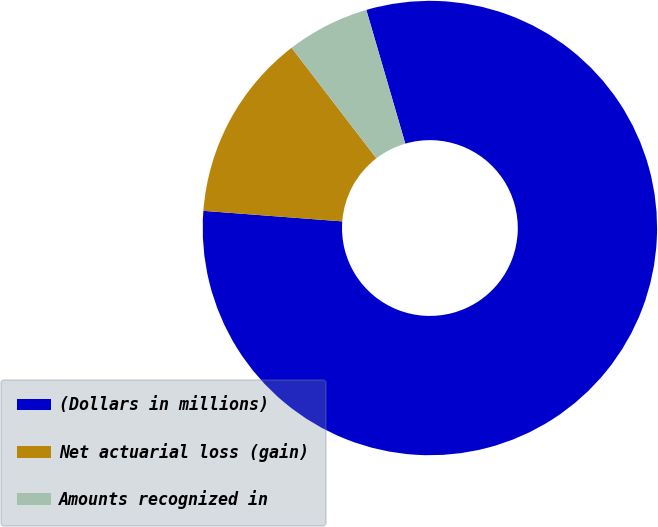Convert chart to OTSL. <chart><loc_0><loc_0><loc_500><loc_500><pie_chart><fcel>(Dollars in millions)<fcel>Net actuarial loss (gain)<fcel>Amounts recognized in<nl><fcel>80.73%<fcel>13.38%<fcel>5.9%<nl></chart> 